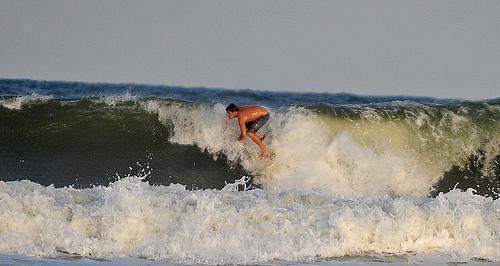How many surfers are in the water?
Give a very brief answer. 1. 